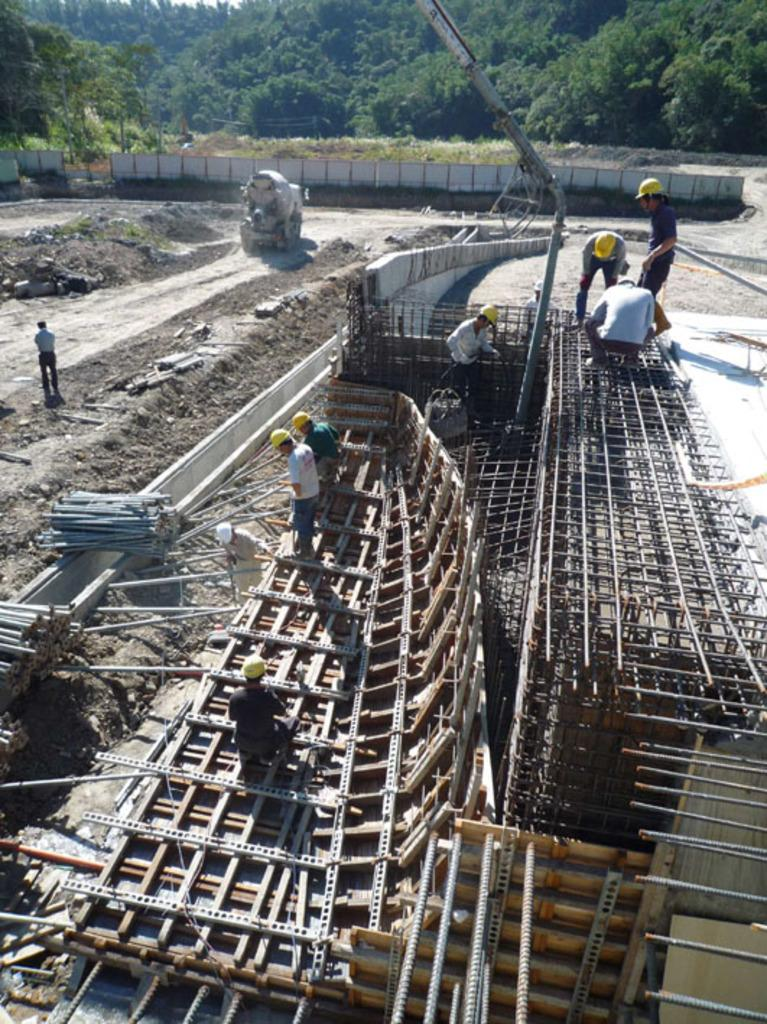What are the men in the foreground of the image doing? The men in the foreground of the image are working in the field, using rods and meshes. What can be seen in the field besides the men? There is a path in the field. What is visible in the background of the image? There are trees in the background of the image, and a truck is moving on the path. What type of sock is the man wearing while working in the field? There is no information about the men's clothing, including socks, in the image. How many boxes can be seen stacked near the truck in the background? There are no boxes visible in the image; only a truck moving on the path in the background. 